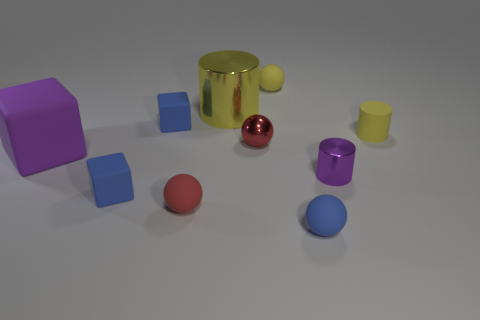Subtract all tiny blue matte cubes. How many cubes are left? 1 Subtract 2 cylinders. How many cylinders are left? 1 Subtract all blue cubes. How many cubes are left? 1 Subtract all blocks. How many objects are left? 7 Subtract all purple cylinders. How many brown balls are left? 0 Subtract all tiny red metallic spheres. Subtract all small yellow cylinders. How many objects are left? 8 Add 4 big purple blocks. How many big purple blocks are left? 5 Add 3 cyan metal objects. How many cyan metal objects exist? 3 Subtract 0 blue cylinders. How many objects are left? 10 Subtract all purple balls. Subtract all yellow cylinders. How many balls are left? 4 